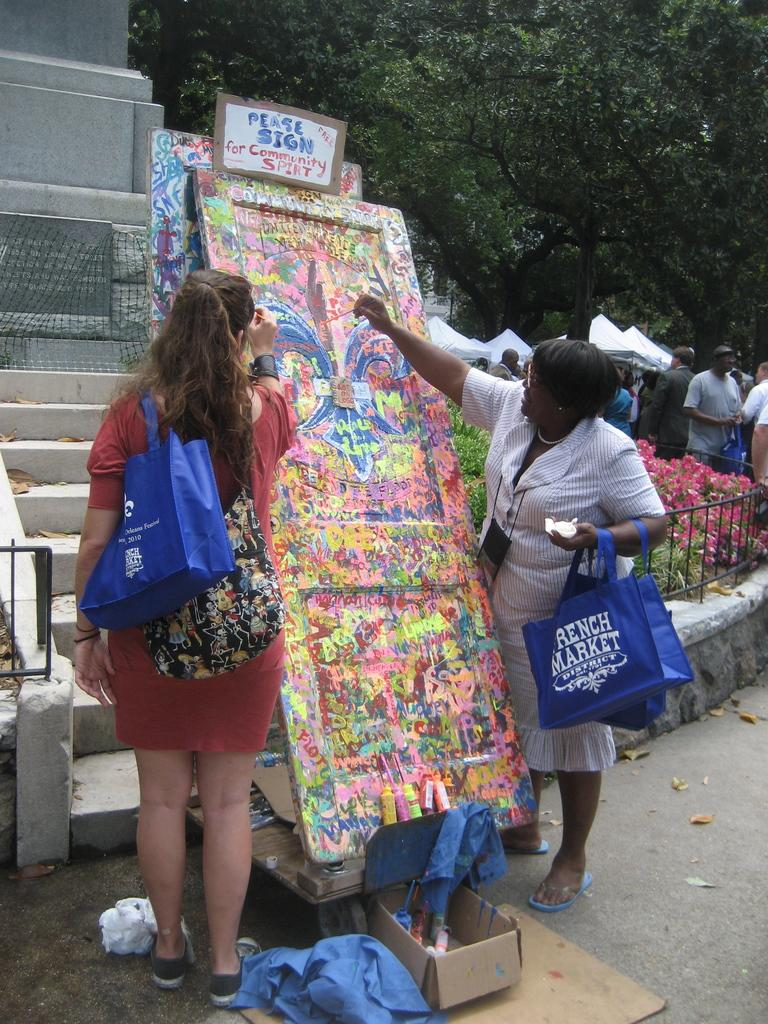How many women are in the image? There are two women in the image. What are the women doing in the image? The women are standing in the image. What are the women carrying in the image? Both women are carrying handbags. What can be seen in the background of the image? There are people and trees in the background of the image. Are the women in the image discussing their plans for the upcoming slave auction? There is no mention of a slave auction or any related topic in the image. The women are simply standing and carrying handbags. 